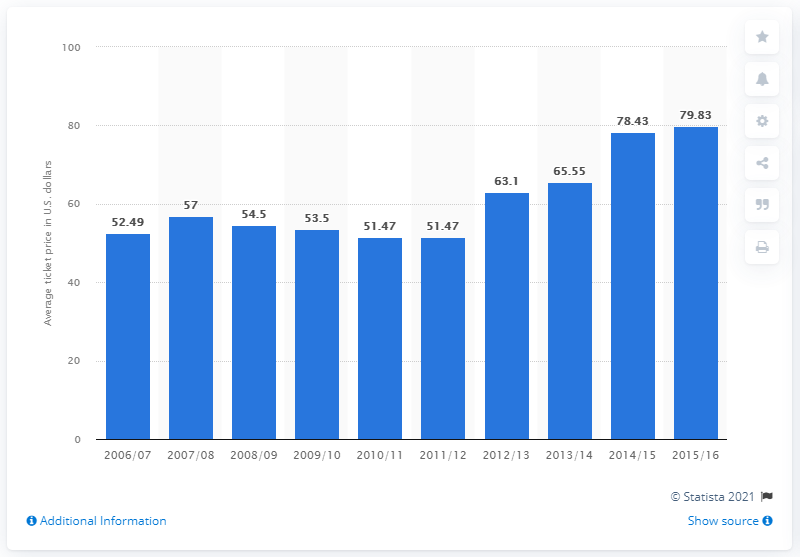Specify some key components in this picture. The average ticket price for Los Angeles Clippers games in the 2006/2007 season was 52.49. 